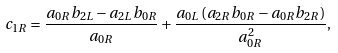<formula> <loc_0><loc_0><loc_500><loc_500>c _ { 1 R } = \frac { a _ { 0 R } b _ { 2 L } - a _ { 2 L } b _ { 0 R } } { a _ { 0 R } } + \frac { a _ { 0 L } \left ( a _ { 2 R } b _ { 0 R } - a _ { 0 R } b _ { 2 R } \right ) } { a _ { 0 R } ^ { 2 } } ,</formula> 